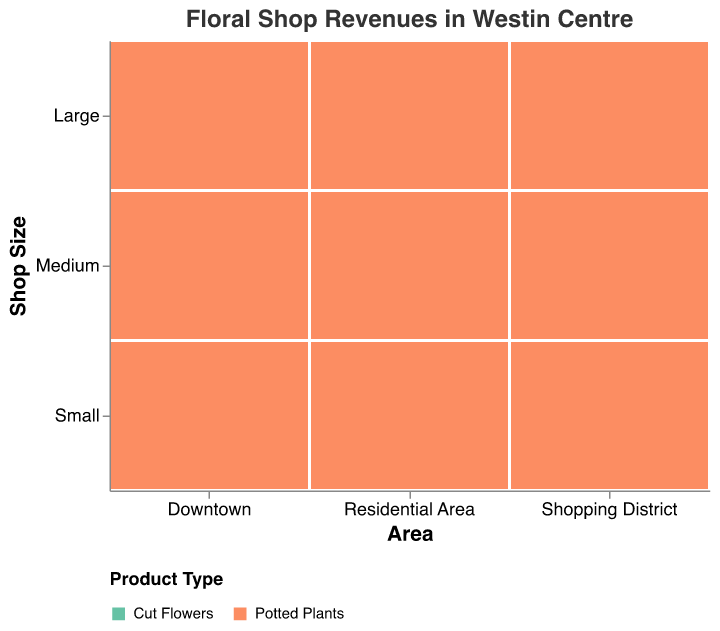What's the title of the plot? The title is indicated at the top of the plot, which specifies what the plot represents.
Answer: Floral Shop Revenues in Westin Centre How is annual revenue visually represented in the plot? The annual revenue is represented by the size of the rectangles in the mosaic plot, with larger sizes indicating higher revenue.
Answer: Size of rectangles Which area has the largest annual revenue for large shops selling cut flowers? Look for the largest rectangle for "Large" shops under "Cut Flowers" and check the corresponding area.
Answer: Shopping District Among medium-sized shops, in which area do potted plants generate higher revenue than cut flowers? Compare the sizes of rectangles for potted plants versus cut flowers in medium-sized shops across all areas.
Answer: Residential Area For small shops, which area has the highest combined revenue from both cut flowers and potted plants? Calculate the sum of the annual revenue from cut flowers and potted plants for small shops in each area and compare.
Answer: Shopping District In which area do large shops generate the most revenue overall? Sum up the annual revenue for both cut flowers and potted plants in large shops across all areas and find the maximum.
Answer: Shopping District Compare the total annual revenue of medium shops in the Downtown versus Residential Area. Which area generates higher revenue? Sum the annual revenues for medium shops (both product types) in Downtown and Residential Area and compare the totals.
Answer: Downtown Do small shops in the Residential Area generate more revenue from cut flowers or potted plants? Compare the sizes of the rectangles for cut flowers and potted plants for small shops in the Residential Area.
Answer: Potted plants Which area shows the highest revenue for small shops selling potted plants? Look for the largest rectangle for "Small" shops under "Potted Plants" and check the corresponding area.
Answer: Residential Area Is there any area where large shops have more revenue from potted plants than cut flowers? Compare the sizes of rectangles for large shops selling cut flowers and potted plants in all areas.
Answer: No 